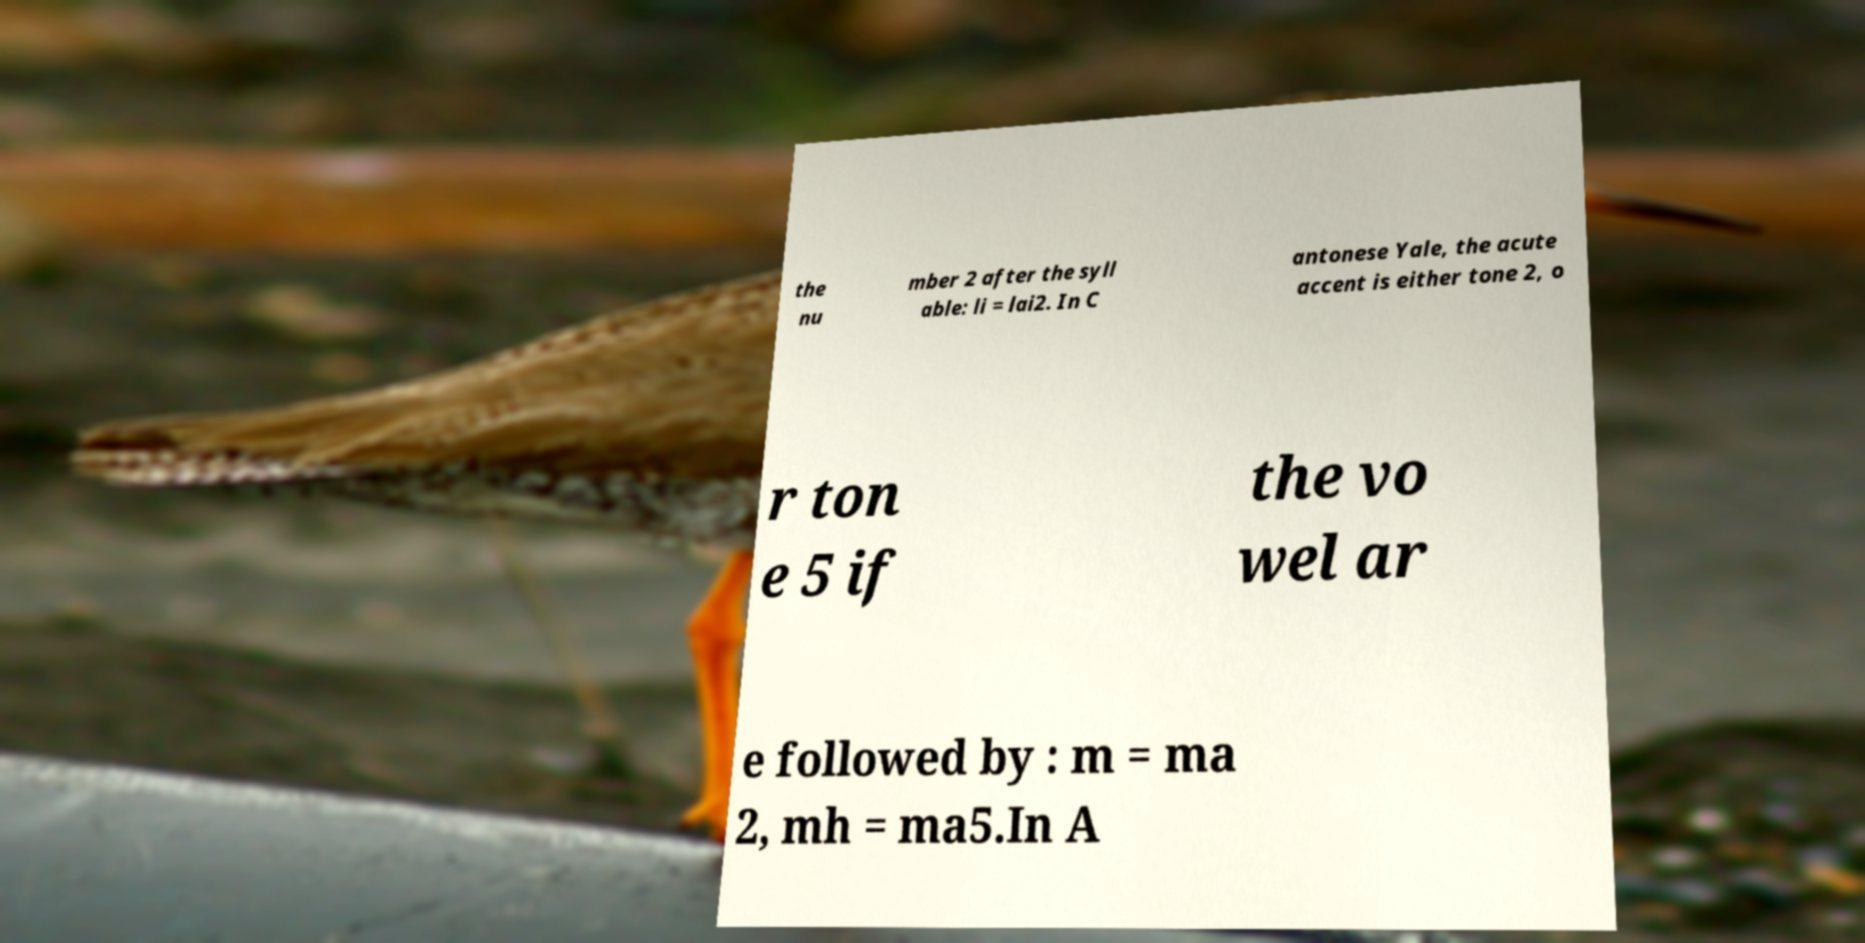There's text embedded in this image that I need extracted. Can you transcribe it verbatim? the nu mber 2 after the syll able: li = lai2. In C antonese Yale, the acute accent is either tone 2, o r ton e 5 if the vo wel ar e followed by : m = ma 2, mh = ma5.In A 